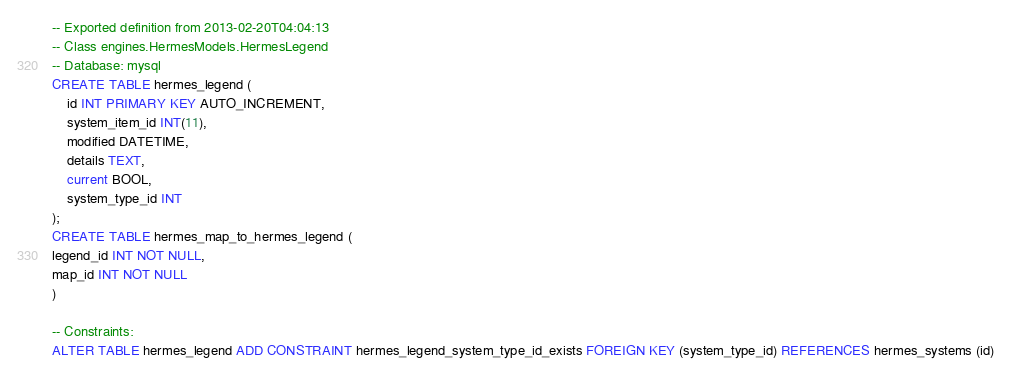<code> <loc_0><loc_0><loc_500><loc_500><_SQL_>-- Exported definition from 2013-02-20T04:04:13
-- Class engines.HermesModels.HermesLegend
-- Database: mysql
CREATE TABLE hermes_legend (
    id INT PRIMARY KEY AUTO_INCREMENT,
    system_item_id INT(11),
    modified DATETIME,
    details TEXT,
    current BOOL,
    system_type_id INT
);
CREATE TABLE hermes_map_to_hermes_legend (
legend_id INT NOT NULL,
map_id INT NOT NULL
)

-- Constraints:
ALTER TABLE hermes_legend ADD CONSTRAINT hermes_legend_system_type_id_exists FOREIGN KEY (system_type_id) REFERENCES hermes_systems (id) 
</code> 